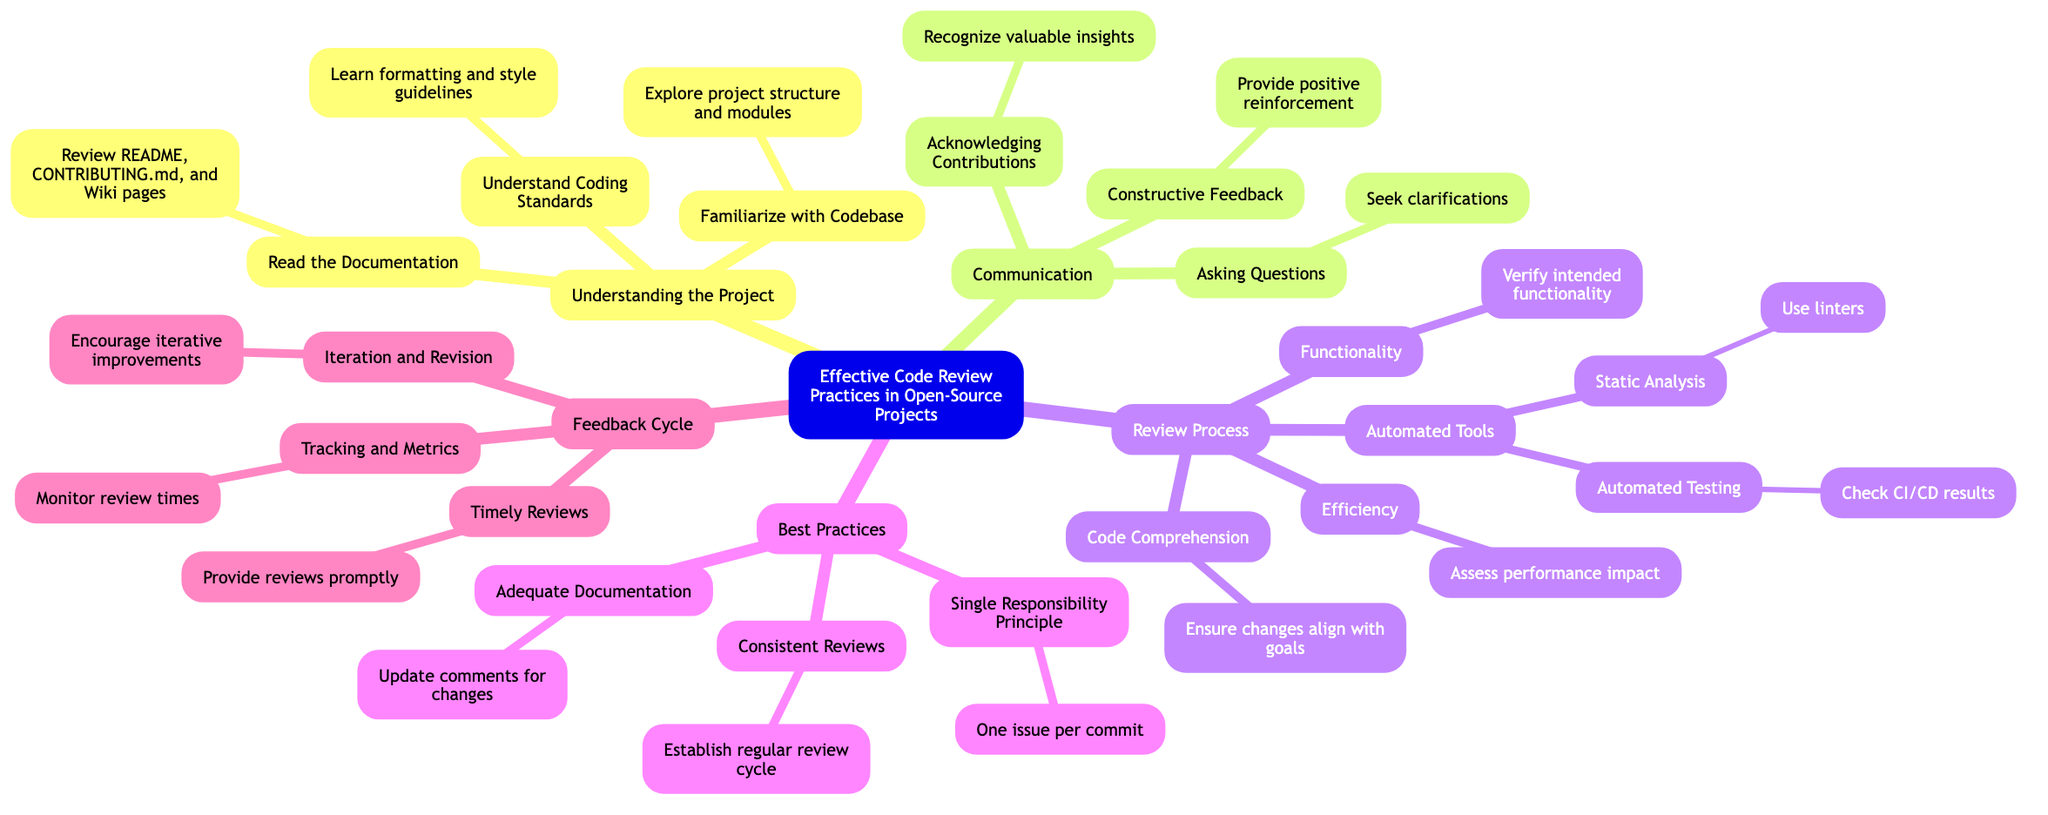What is the main topic of the mind map? The main topic is indicated at the center of the mind map, which is "Effective Code Review Practices in Open-Source Projects."
Answer: Effective Code Review Practices in Open-Source Projects How many major sections are in the mind map? The mind map has five major sections branching from the main topic: Understanding the Project, Communication, Review Process, Best Practices, and Feedback Cycle. By counting these sections, we can determine that there are five.
Answer: 5 What does "Automated Testing" fall under? By following the relationships in the mind map, "Automated Testing" is a subcategory under "Automated Tools," which is part of the "Review Process" section.
Answer: Review Process What is suggested under "Communication" for giving feedback? The subcategory under "Communication" that deals with feedback is "Constructive Feedback," which involves providing positive reinforcement and suggesting improvements in a polite manner.
Answer: Provide positive reinforcement How many elements are included in the "Review Process"? The "Review Process" section has four main elements: Automated Tools, Code Comprehension, Functionality, and Efficiency. Counting these gives a total of four elements.
Answer: 4 What does the "Feedback Cycle" suggest about reviews? The "Feedback Cycle" underlines the importance of "Timely Reviews," which emphasizes providing reviews in a reasonable timeframe to maintain the momentum in the project.
Answer: Provide reviews promptly What principle should each commit adhere to according to best practices? The best practices outline the "Single Responsibility Principle," which states that each commit should address one particular issue or feature, ensuring clarity and focus.
Answer: One issue per commit What tool types are suggested under "Automated Tools"? The mind map specifies two types of tools under "Automated Tools": Static Analysis and Automated Testing. Both are key components in enhancing the code review process.
Answer: Static Analysis and Automated Testing What does "Tracking and Metrics" refer to in the context of the feedback cycle? "Tracking and Metrics" refers to the idea of monitoring review times and feedback loops, suggesting that the progress of reviews should be tracked using relevant tools like GitHub Insights.
Answer: Monitor review times 